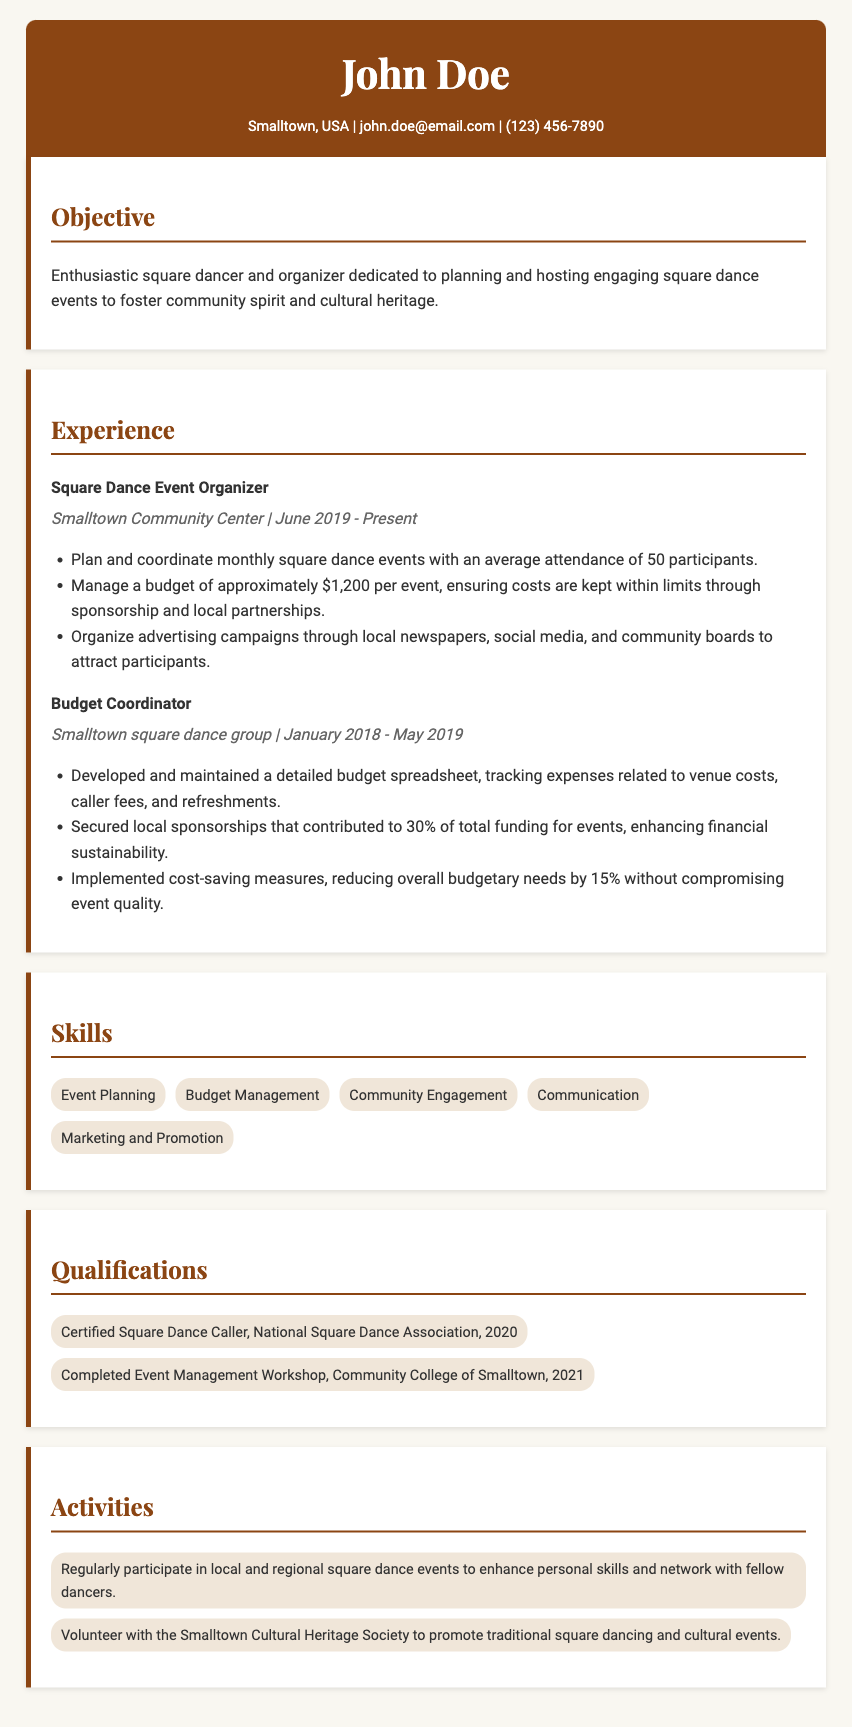what is the position title of John Doe? The document states that the position title is "Square Dance Event Organizer."
Answer: Square Dance Event Organizer what is the main budget managed per event? The document indicates that the budget managed for each event is approximately $1,200.
Answer: $1,200 what type of workshops has John Doe completed? The qualifications section specifies that he completed an "Event Management Workshop."
Answer: Event Management Workshop how many participants attend the square dance events on average? The document mentions that the average attendance for the events is 50 participants.
Answer: 50 what percentage of total funding did local sponsorships contribute? According to the document, local sponsorships contributed to 30% of total funding.
Answer: 30% what organization is John Doe certified by as a square dance caller? The qualifications section states that he is certified by the "National Square Dance Association."
Answer: National Square Dance Association when did John Doe start organizing square dance events? The document indicates that he started organizing events in June 2019.
Answer: June 2019 what is the goal of John Doe's square dance events? The objective section mentions that the goal is to foster "community spirit and cultural heritage."
Answer: community spirit and cultural heritage what is a cost-saving achievement mentioned in the document? The document highlights that he reduced overall budgetary needs by 15% without compromising event quality.
Answer: 15% 